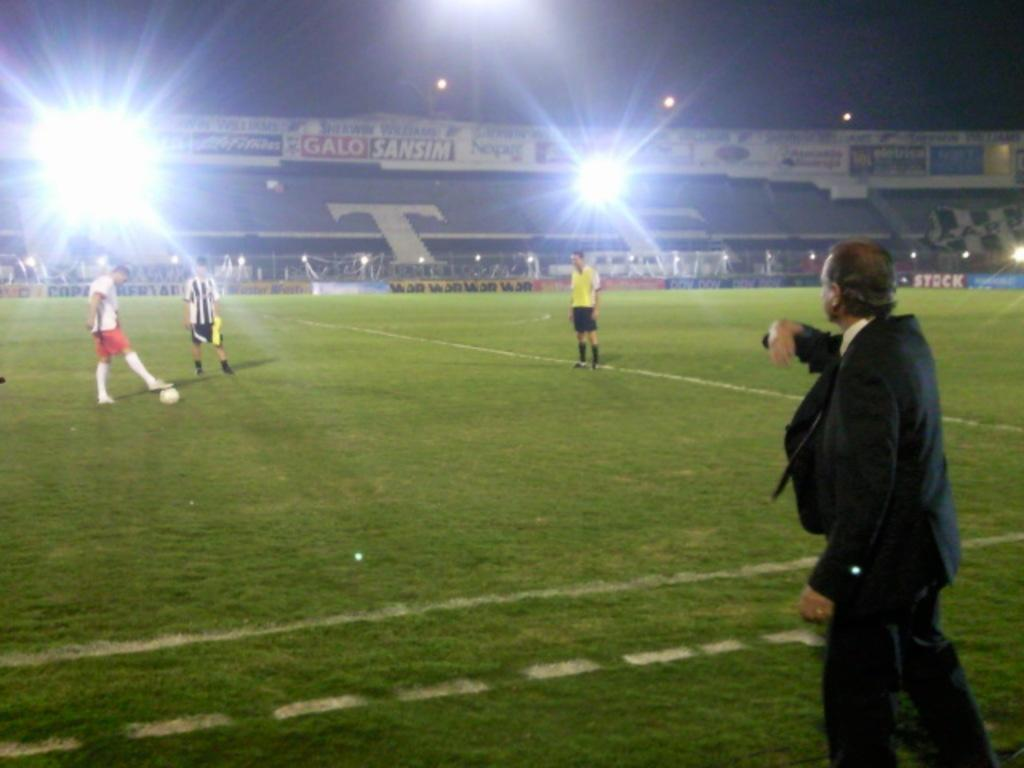Provide a one-sentence caption for the provided image. night time on soccer field with man in suit in front and stands have a large T on it in background. 